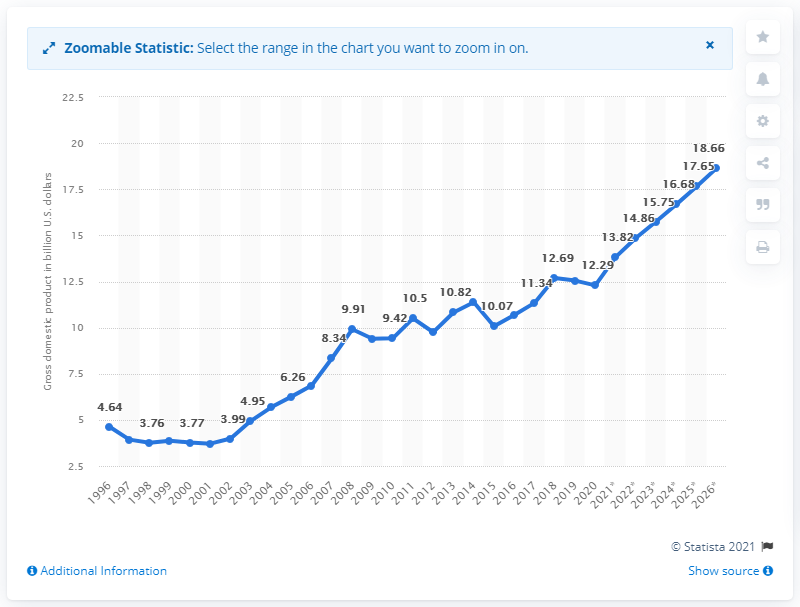Give some essential details in this illustration. In 2020, the gross domestic product of North Macedonia was $12.29 billion in dollars. 